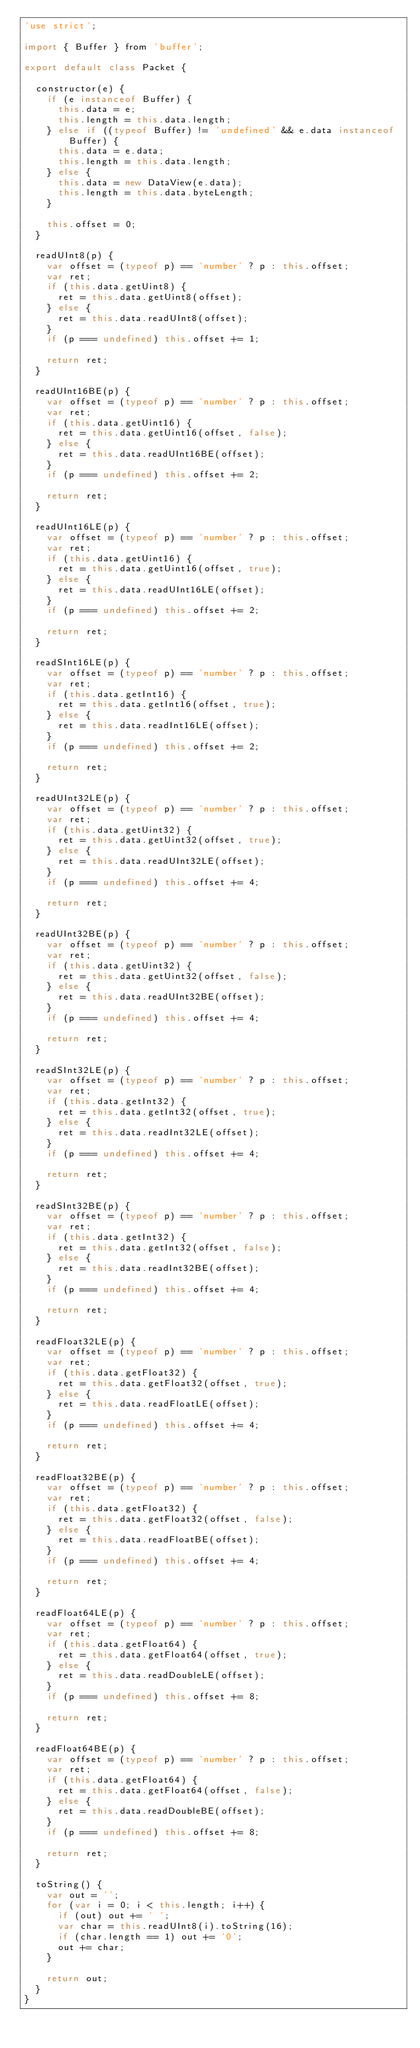Convert code to text. <code><loc_0><loc_0><loc_500><loc_500><_JavaScript_>'use strict';

import { Buffer } from 'buffer';

export default class Packet {

  constructor(e) {
    if (e instanceof Buffer) {
      this.data = e;
      this.length = this.data.length;
    } else if ((typeof Buffer) != 'undefined' && e.data instanceof Buffer) {
      this.data = e.data;
      this.length = this.data.length;
    } else {
      this.data = new DataView(e.data);
      this.length = this.data.byteLength;
    }

    this.offset = 0;
  }

  readUInt8(p) {
    var offset = (typeof p) == 'number' ? p : this.offset;
    var ret;
    if (this.data.getUint8) {
      ret = this.data.getUint8(offset);
    } else {
      ret = this.data.readUInt8(offset);
    }
    if (p === undefined) this.offset += 1;

    return ret;
  }

  readUInt16BE(p) {
    var offset = (typeof p) == 'number' ? p : this.offset;
    var ret;
    if (this.data.getUint16) {
      ret = this.data.getUint16(offset, false);
    } else {
      ret = this.data.readUInt16BE(offset);
    }
    if (p === undefined) this.offset += 2;

    return ret;
  }

  readUInt16LE(p) {
    var offset = (typeof p) == 'number' ? p : this.offset;
    var ret;
    if (this.data.getUint16) {
      ret = this.data.getUint16(offset, true);
    } else {
      ret = this.data.readUInt16LE(offset);
    }
    if (p === undefined) this.offset += 2;

    return ret;
  }

  readSInt16LE(p) {
    var offset = (typeof p) == 'number' ? p : this.offset;
    var ret;
    if (this.data.getInt16) {
      ret = this.data.getInt16(offset, true);
    } else {
      ret = this.data.readInt16LE(offset);
    }
    if (p === undefined) this.offset += 2;

    return ret;
  }

  readUInt32LE(p) {
    var offset = (typeof p) == 'number' ? p : this.offset;
    var ret;
    if (this.data.getUint32) {
      ret = this.data.getUint32(offset, true);
    } else {
      ret = this.data.readUInt32LE(offset);
    }
    if (p === undefined) this.offset += 4;

    return ret;
  }

  readUInt32BE(p) {
    var offset = (typeof p) == 'number' ? p : this.offset;
    var ret;
    if (this.data.getUint32) {
      ret = this.data.getUint32(offset, false);
    } else {
      ret = this.data.readUInt32BE(offset);
    }
    if (p === undefined) this.offset += 4;

    return ret;
  }

  readSInt32LE(p) {
    var offset = (typeof p) == 'number' ? p : this.offset;
    var ret;
    if (this.data.getInt32) {
      ret = this.data.getInt32(offset, true);
    } else {
      ret = this.data.readInt32LE(offset);
    }
    if (p === undefined) this.offset += 4;

    return ret;
  }

  readSInt32BE(p) {
    var offset = (typeof p) == 'number' ? p : this.offset;
    var ret;
    if (this.data.getInt32) {
      ret = this.data.getInt32(offset, false);
    } else {
      ret = this.data.readInt32BE(offset);
    }
    if (p === undefined) this.offset += 4;

    return ret;
  }

  readFloat32LE(p) {
    var offset = (typeof p) == 'number' ? p : this.offset;
    var ret;
    if (this.data.getFloat32) {
      ret = this.data.getFloat32(offset, true);
    } else {
      ret = this.data.readFloatLE(offset);
    }
    if (p === undefined) this.offset += 4;

    return ret;
  }

  readFloat32BE(p) {
    var offset = (typeof p) == 'number' ? p : this.offset;
    var ret;
    if (this.data.getFloat32) {
      ret = this.data.getFloat32(offset, false);
    } else {
      ret = this.data.readFloatBE(offset);
    }
    if (p === undefined) this.offset += 4;

    return ret;
  }

  readFloat64LE(p) {
    var offset = (typeof p) == 'number' ? p : this.offset;
    var ret;
    if (this.data.getFloat64) {
      ret = this.data.getFloat64(offset, true);
    } else {
      ret = this.data.readDoubleLE(offset);
    }
    if (p === undefined) this.offset += 8;

    return ret;
  }

  readFloat64BE(p) {
    var offset = (typeof p) == 'number' ? p : this.offset;
    var ret;
    if (this.data.getFloat64) {
      ret = this.data.getFloat64(offset, false);
    } else {
      ret = this.data.readDoubleBE(offset);
    }
    if (p === undefined) this.offset += 8;

    return ret;
  }

  toString() {
    var out = '';
    for (var i = 0; i < this.length; i++) {
      if (out) out += ' ';
      var char = this.readUInt8(i).toString(16);
      if (char.length == 1) out += '0';
      out += char;
    }

    return out;
  }
}
</code> 